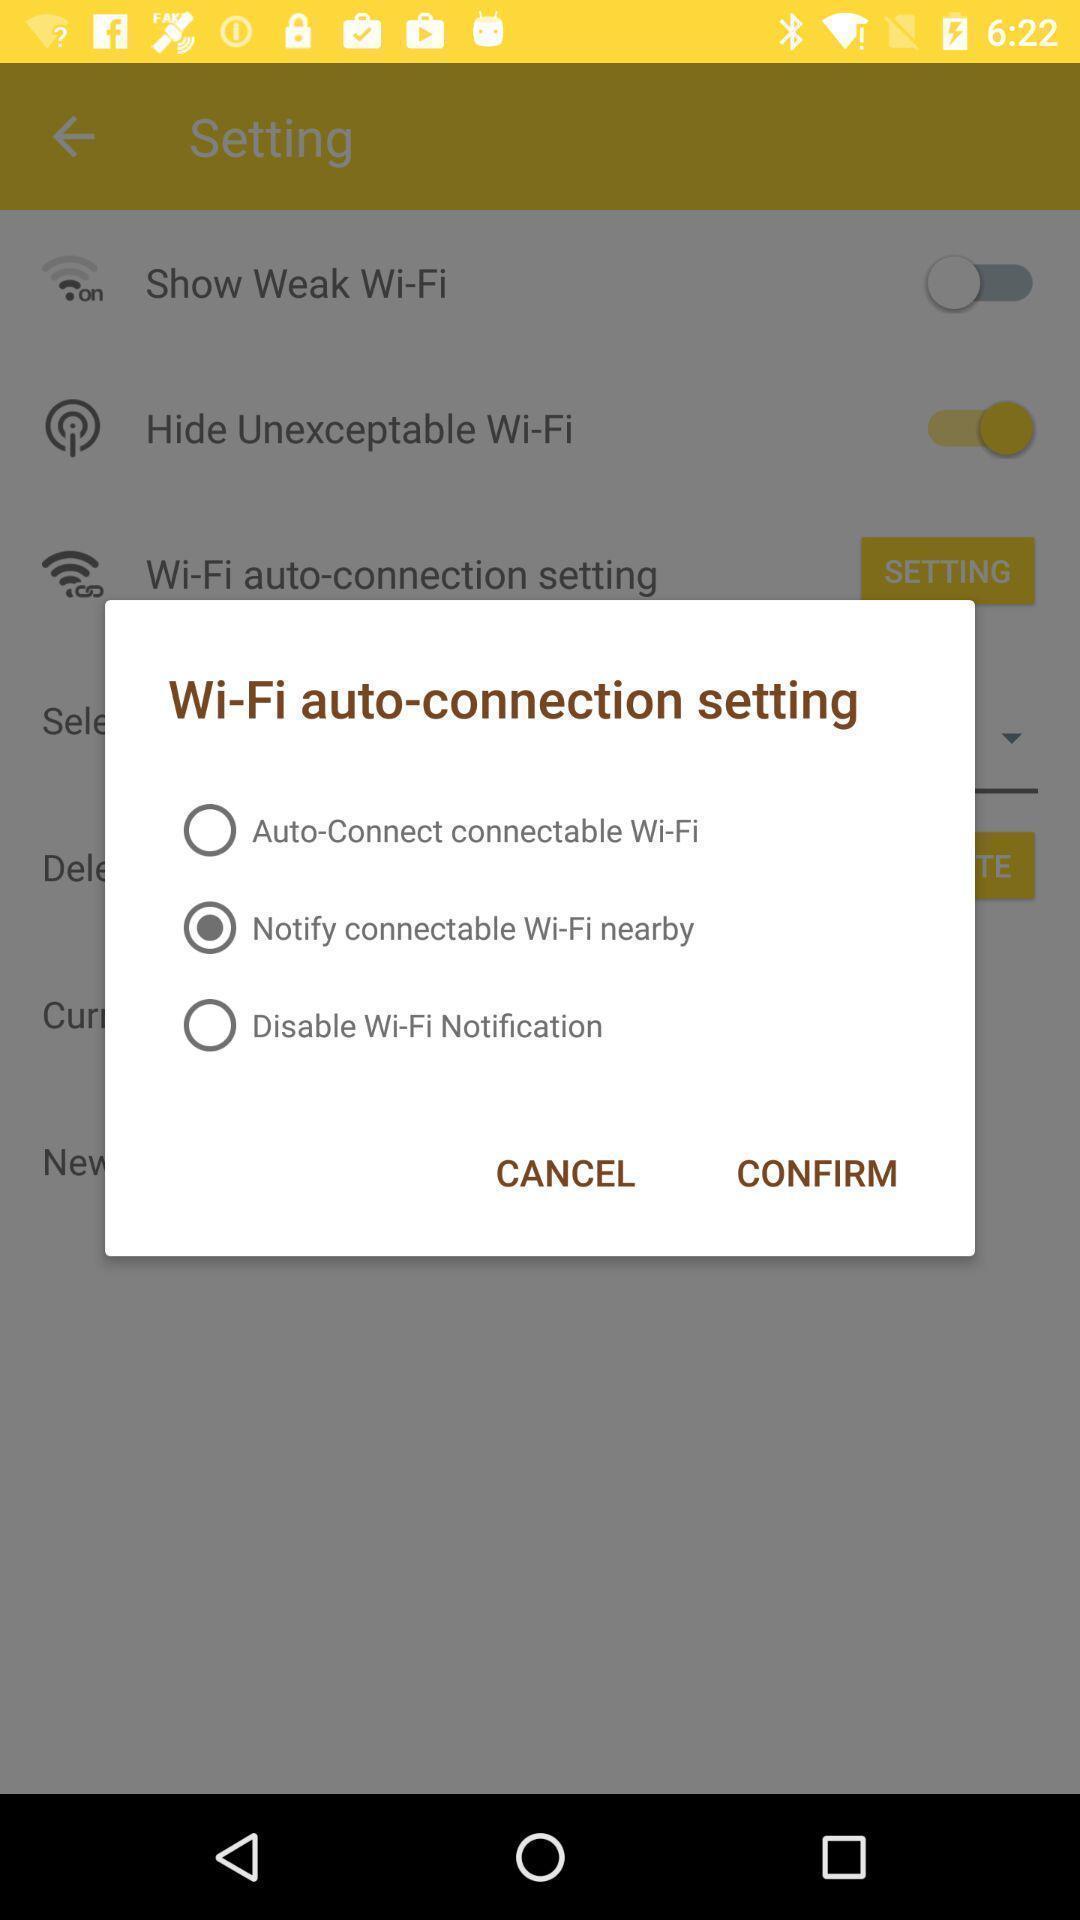Provide a textual representation of this image. Pop-up displaying the wifi auto connection. 